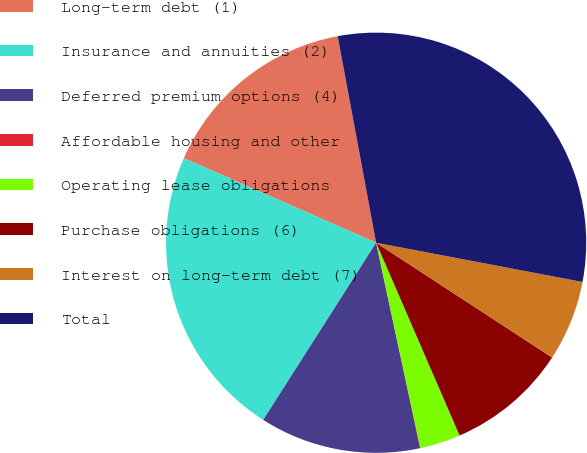Convert chart. <chart><loc_0><loc_0><loc_500><loc_500><pie_chart><fcel>Long-term debt (1)<fcel>Insurance and annuities (2)<fcel>Deferred premium options (4)<fcel>Affordable housing and other<fcel>Operating lease obligations<fcel>Purchase obligations (6)<fcel>Interest on long-term debt (7)<fcel>Total<nl><fcel>15.48%<fcel>22.57%<fcel>12.39%<fcel>0.03%<fcel>3.12%<fcel>9.3%<fcel>6.21%<fcel>30.93%<nl></chart> 